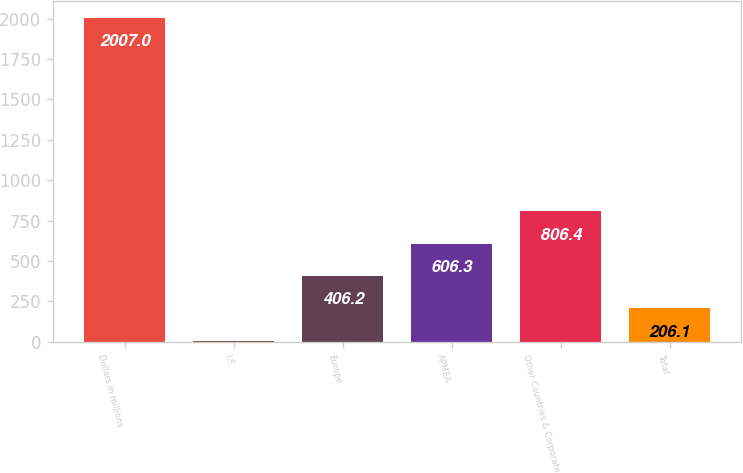<chart> <loc_0><loc_0><loc_500><loc_500><bar_chart><fcel>Dollars in millions<fcel>US<fcel>Europe<fcel>APMEA<fcel>Other Countries & Corporate<fcel>Total<nl><fcel>2007<fcel>6<fcel>406.2<fcel>606.3<fcel>806.4<fcel>206.1<nl></chart> 